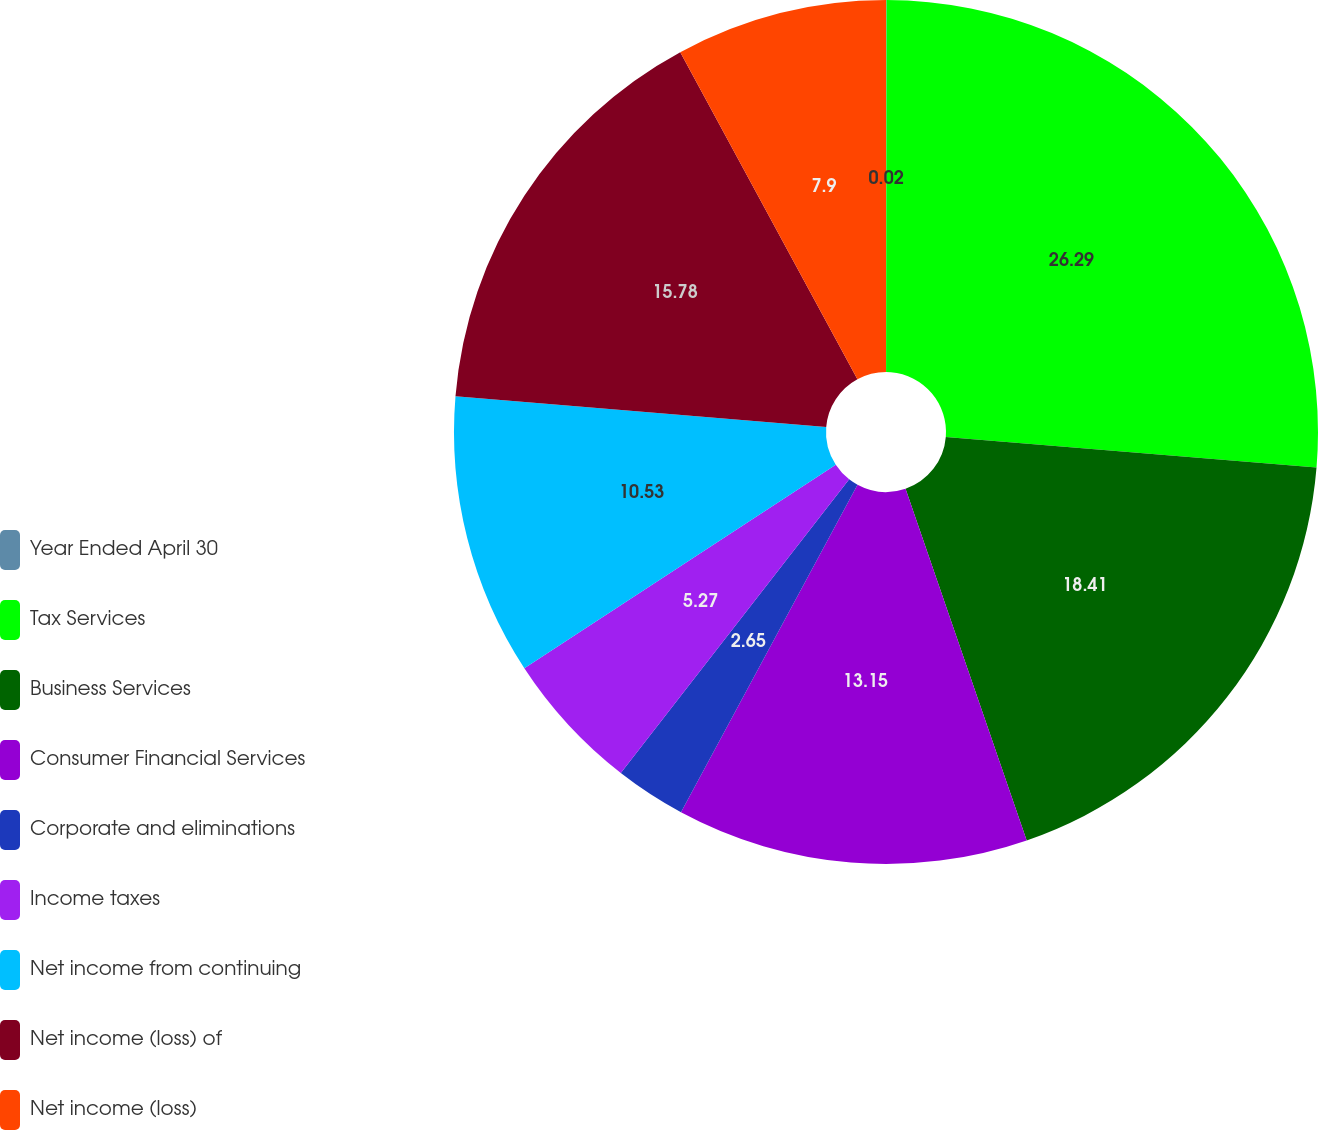Convert chart. <chart><loc_0><loc_0><loc_500><loc_500><pie_chart><fcel>Year Ended April 30<fcel>Tax Services<fcel>Business Services<fcel>Consumer Financial Services<fcel>Corporate and eliminations<fcel>Income taxes<fcel>Net income from continuing<fcel>Net income (loss) of<fcel>Net income (loss)<nl><fcel>0.02%<fcel>26.29%<fcel>18.41%<fcel>13.15%<fcel>2.65%<fcel>5.27%<fcel>10.53%<fcel>15.78%<fcel>7.9%<nl></chart> 